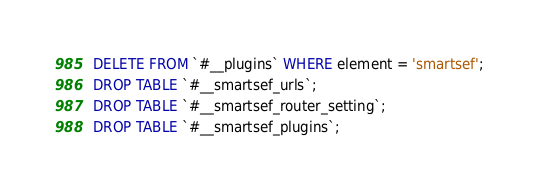<code> <loc_0><loc_0><loc_500><loc_500><_SQL_>DELETE FROM `#__plugins` WHERE element = 'smartsef';
DROP TABLE `#__smartsef_urls`;
DROP TABLE `#__smartsef_router_setting`;
DROP TABLE `#__smartsef_plugins`;</code> 